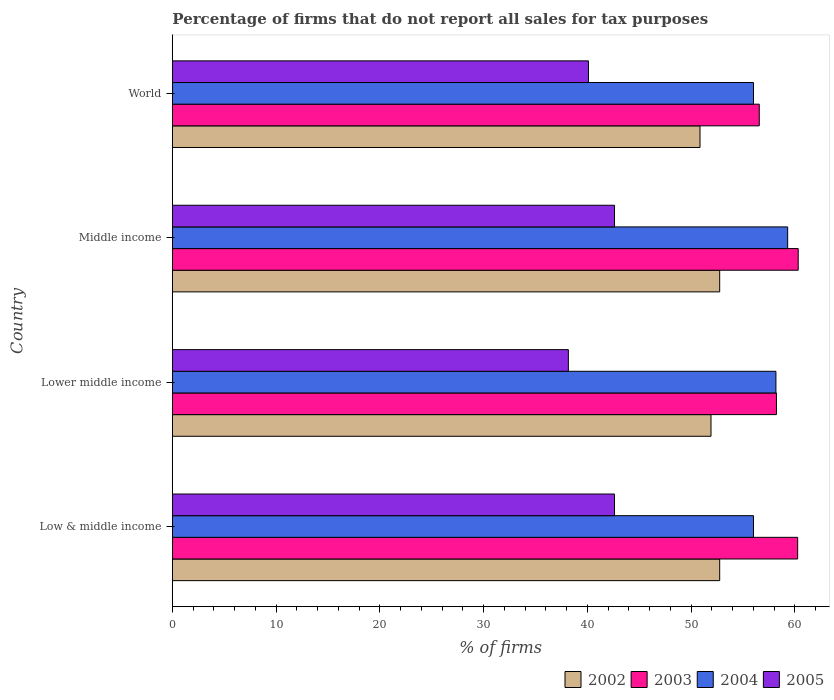How many groups of bars are there?
Ensure brevity in your answer.  4. How many bars are there on the 1st tick from the top?
Ensure brevity in your answer.  4. What is the label of the 3rd group of bars from the top?
Provide a short and direct response. Lower middle income. In how many cases, is the number of bars for a given country not equal to the number of legend labels?
Make the answer very short. 0. What is the percentage of firms that do not report all sales for tax purposes in 2005 in Low & middle income?
Offer a terse response. 42.61. Across all countries, what is the maximum percentage of firms that do not report all sales for tax purposes in 2003?
Keep it short and to the point. 60.31. Across all countries, what is the minimum percentage of firms that do not report all sales for tax purposes in 2004?
Provide a short and direct response. 56.01. In which country was the percentage of firms that do not report all sales for tax purposes in 2002 maximum?
Your answer should be very brief. Low & middle income. In which country was the percentage of firms that do not report all sales for tax purposes in 2002 minimum?
Give a very brief answer. World. What is the total percentage of firms that do not report all sales for tax purposes in 2004 in the graph?
Your response must be concise. 229.47. What is the difference between the percentage of firms that do not report all sales for tax purposes in 2004 in Middle income and the percentage of firms that do not report all sales for tax purposes in 2005 in World?
Provide a succinct answer. 19.2. What is the average percentage of firms that do not report all sales for tax purposes in 2002 per country?
Ensure brevity in your answer.  52.06. What is the difference between the percentage of firms that do not report all sales for tax purposes in 2003 and percentage of firms that do not report all sales for tax purposes in 2005 in Lower middle income?
Your answer should be compact. 20.06. In how many countries, is the percentage of firms that do not report all sales for tax purposes in 2004 greater than 48 %?
Provide a short and direct response. 4. What is the ratio of the percentage of firms that do not report all sales for tax purposes in 2002 in Low & middle income to that in Lower middle income?
Your response must be concise. 1.02. Is the difference between the percentage of firms that do not report all sales for tax purposes in 2003 in Middle income and World greater than the difference between the percentage of firms that do not report all sales for tax purposes in 2005 in Middle income and World?
Offer a terse response. Yes. What is the difference between the highest and the second highest percentage of firms that do not report all sales for tax purposes in 2004?
Your response must be concise. 1.13. What is the difference between the highest and the lowest percentage of firms that do not report all sales for tax purposes in 2002?
Your response must be concise. 1.89. In how many countries, is the percentage of firms that do not report all sales for tax purposes in 2005 greater than the average percentage of firms that do not report all sales for tax purposes in 2005 taken over all countries?
Your answer should be very brief. 2. Is the sum of the percentage of firms that do not report all sales for tax purposes in 2002 in Middle income and World greater than the maximum percentage of firms that do not report all sales for tax purposes in 2004 across all countries?
Your answer should be very brief. Yes. Is it the case that in every country, the sum of the percentage of firms that do not report all sales for tax purposes in 2002 and percentage of firms that do not report all sales for tax purposes in 2004 is greater than the sum of percentage of firms that do not report all sales for tax purposes in 2003 and percentage of firms that do not report all sales for tax purposes in 2005?
Your answer should be very brief. Yes. Is it the case that in every country, the sum of the percentage of firms that do not report all sales for tax purposes in 2003 and percentage of firms that do not report all sales for tax purposes in 2005 is greater than the percentage of firms that do not report all sales for tax purposes in 2004?
Offer a very short reply. Yes. How many bars are there?
Your response must be concise. 16. Are all the bars in the graph horizontal?
Your response must be concise. Yes. Does the graph contain any zero values?
Your answer should be compact. No. Does the graph contain grids?
Offer a terse response. No. Where does the legend appear in the graph?
Provide a succinct answer. Bottom right. How are the legend labels stacked?
Give a very brief answer. Horizontal. What is the title of the graph?
Your answer should be very brief. Percentage of firms that do not report all sales for tax purposes. What is the label or title of the X-axis?
Your answer should be compact. % of firms. What is the label or title of the Y-axis?
Give a very brief answer. Country. What is the % of firms of 2002 in Low & middle income?
Provide a succinct answer. 52.75. What is the % of firms in 2003 in Low & middle income?
Give a very brief answer. 60.26. What is the % of firms of 2004 in Low & middle income?
Your answer should be compact. 56.01. What is the % of firms of 2005 in Low & middle income?
Provide a succinct answer. 42.61. What is the % of firms in 2002 in Lower middle income?
Keep it short and to the point. 51.91. What is the % of firms in 2003 in Lower middle income?
Ensure brevity in your answer.  58.22. What is the % of firms in 2004 in Lower middle income?
Give a very brief answer. 58.16. What is the % of firms in 2005 in Lower middle income?
Provide a succinct answer. 38.16. What is the % of firms in 2002 in Middle income?
Ensure brevity in your answer.  52.75. What is the % of firms of 2003 in Middle income?
Your answer should be very brief. 60.31. What is the % of firms in 2004 in Middle income?
Keep it short and to the point. 59.3. What is the % of firms in 2005 in Middle income?
Provide a short and direct response. 42.61. What is the % of firms in 2002 in World?
Provide a succinct answer. 50.85. What is the % of firms in 2003 in World?
Offer a terse response. 56.56. What is the % of firms of 2004 in World?
Your response must be concise. 56.01. What is the % of firms of 2005 in World?
Your response must be concise. 40.1. Across all countries, what is the maximum % of firms in 2002?
Your answer should be compact. 52.75. Across all countries, what is the maximum % of firms of 2003?
Ensure brevity in your answer.  60.31. Across all countries, what is the maximum % of firms in 2004?
Provide a succinct answer. 59.3. Across all countries, what is the maximum % of firms of 2005?
Provide a succinct answer. 42.61. Across all countries, what is the minimum % of firms in 2002?
Offer a very short reply. 50.85. Across all countries, what is the minimum % of firms of 2003?
Offer a terse response. 56.56. Across all countries, what is the minimum % of firms of 2004?
Ensure brevity in your answer.  56.01. Across all countries, what is the minimum % of firms in 2005?
Offer a very short reply. 38.16. What is the total % of firms in 2002 in the graph?
Ensure brevity in your answer.  208.25. What is the total % of firms in 2003 in the graph?
Offer a very short reply. 235.35. What is the total % of firms of 2004 in the graph?
Give a very brief answer. 229.47. What is the total % of firms of 2005 in the graph?
Your answer should be very brief. 163.48. What is the difference between the % of firms in 2002 in Low & middle income and that in Lower middle income?
Provide a short and direct response. 0.84. What is the difference between the % of firms of 2003 in Low & middle income and that in Lower middle income?
Your answer should be compact. 2.04. What is the difference between the % of firms in 2004 in Low & middle income and that in Lower middle income?
Your answer should be compact. -2.16. What is the difference between the % of firms of 2005 in Low & middle income and that in Lower middle income?
Offer a terse response. 4.45. What is the difference between the % of firms of 2002 in Low & middle income and that in Middle income?
Give a very brief answer. 0. What is the difference between the % of firms in 2003 in Low & middle income and that in Middle income?
Provide a short and direct response. -0.05. What is the difference between the % of firms of 2004 in Low & middle income and that in Middle income?
Make the answer very short. -3.29. What is the difference between the % of firms of 2005 in Low & middle income and that in Middle income?
Give a very brief answer. 0. What is the difference between the % of firms of 2002 in Low & middle income and that in World?
Your answer should be very brief. 1.89. What is the difference between the % of firms of 2003 in Low & middle income and that in World?
Provide a short and direct response. 3.7. What is the difference between the % of firms in 2004 in Low & middle income and that in World?
Provide a succinct answer. 0. What is the difference between the % of firms in 2005 in Low & middle income and that in World?
Ensure brevity in your answer.  2.51. What is the difference between the % of firms of 2002 in Lower middle income and that in Middle income?
Give a very brief answer. -0.84. What is the difference between the % of firms of 2003 in Lower middle income and that in Middle income?
Your answer should be compact. -2.09. What is the difference between the % of firms of 2004 in Lower middle income and that in Middle income?
Provide a short and direct response. -1.13. What is the difference between the % of firms in 2005 in Lower middle income and that in Middle income?
Provide a short and direct response. -4.45. What is the difference between the % of firms in 2002 in Lower middle income and that in World?
Provide a short and direct response. 1.06. What is the difference between the % of firms in 2003 in Lower middle income and that in World?
Your response must be concise. 1.66. What is the difference between the % of firms of 2004 in Lower middle income and that in World?
Ensure brevity in your answer.  2.16. What is the difference between the % of firms in 2005 in Lower middle income and that in World?
Ensure brevity in your answer.  -1.94. What is the difference between the % of firms in 2002 in Middle income and that in World?
Your answer should be compact. 1.89. What is the difference between the % of firms of 2003 in Middle income and that in World?
Provide a short and direct response. 3.75. What is the difference between the % of firms in 2004 in Middle income and that in World?
Offer a terse response. 3.29. What is the difference between the % of firms in 2005 in Middle income and that in World?
Provide a short and direct response. 2.51. What is the difference between the % of firms of 2002 in Low & middle income and the % of firms of 2003 in Lower middle income?
Provide a succinct answer. -5.47. What is the difference between the % of firms of 2002 in Low & middle income and the % of firms of 2004 in Lower middle income?
Keep it short and to the point. -5.42. What is the difference between the % of firms in 2002 in Low & middle income and the % of firms in 2005 in Lower middle income?
Your response must be concise. 14.58. What is the difference between the % of firms of 2003 in Low & middle income and the % of firms of 2004 in Lower middle income?
Offer a very short reply. 2.1. What is the difference between the % of firms in 2003 in Low & middle income and the % of firms in 2005 in Lower middle income?
Your answer should be very brief. 22.1. What is the difference between the % of firms in 2004 in Low & middle income and the % of firms in 2005 in Lower middle income?
Offer a terse response. 17.84. What is the difference between the % of firms of 2002 in Low & middle income and the % of firms of 2003 in Middle income?
Make the answer very short. -7.57. What is the difference between the % of firms of 2002 in Low & middle income and the % of firms of 2004 in Middle income?
Your answer should be very brief. -6.55. What is the difference between the % of firms in 2002 in Low & middle income and the % of firms in 2005 in Middle income?
Your answer should be very brief. 10.13. What is the difference between the % of firms of 2003 in Low & middle income and the % of firms of 2004 in Middle income?
Your answer should be very brief. 0.96. What is the difference between the % of firms in 2003 in Low & middle income and the % of firms in 2005 in Middle income?
Keep it short and to the point. 17.65. What is the difference between the % of firms of 2004 in Low & middle income and the % of firms of 2005 in Middle income?
Keep it short and to the point. 13.39. What is the difference between the % of firms of 2002 in Low & middle income and the % of firms of 2003 in World?
Your response must be concise. -3.81. What is the difference between the % of firms in 2002 in Low & middle income and the % of firms in 2004 in World?
Keep it short and to the point. -3.26. What is the difference between the % of firms in 2002 in Low & middle income and the % of firms in 2005 in World?
Offer a very short reply. 12.65. What is the difference between the % of firms of 2003 in Low & middle income and the % of firms of 2004 in World?
Your response must be concise. 4.25. What is the difference between the % of firms of 2003 in Low & middle income and the % of firms of 2005 in World?
Give a very brief answer. 20.16. What is the difference between the % of firms in 2004 in Low & middle income and the % of firms in 2005 in World?
Offer a very short reply. 15.91. What is the difference between the % of firms in 2002 in Lower middle income and the % of firms in 2003 in Middle income?
Keep it short and to the point. -8.4. What is the difference between the % of firms in 2002 in Lower middle income and the % of firms in 2004 in Middle income?
Make the answer very short. -7.39. What is the difference between the % of firms of 2002 in Lower middle income and the % of firms of 2005 in Middle income?
Your answer should be compact. 9.3. What is the difference between the % of firms of 2003 in Lower middle income and the % of firms of 2004 in Middle income?
Offer a terse response. -1.08. What is the difference between the % of firms of 2003 in Lower middle income and the % of firms of 2005 in Middle income?
Your answer should be very brief. 15.61. What is the difference between the % of firms in 2004 in Lower middle income and the % of firms in 2005 in Middle income?
Offer a very short reply. 15.55. What is the difference between the % of firms of 2002 in Lower middle income and the % of firms of 2003 in World?
Provide a succinct answer. -4.65. What is the difference between the % of firms in 2002 in Lower middle income and the % of firms in 2004 in World?
Offer a very short reply. -4.1. What is the difference between the % of firms of 2002 in Lower middle income and the % of firms of 2005 in World?
Provide a succinct answer. 11.81. What is the difference between the % of firms of 2003 in Lower middle income and the % of firms of 2004 in World?
Your response must be concise. 2.21. What is the difference between the % of firms in 2003 in Lower middle income and the % of firms in 2005 in World?
Keep it short and to the point. 18.12. What is the difference between the % of firms in 2004 in Lower middle income and the % of firms in 2005 in World?
Offer a terse response. 18.07. What is the difference between the % of firms of 2002 in Middle income and the % of firms of 2003 in World?
Make the answer very short. -3.81. What is the difference between the % of firms of 2002 in Middle income and the % of firms of 2004 in World?
Your answer should be compact. -3.26. What is the difference between the % of firms of 2002 in Middle income and the % of firms of 2005 in World?
Your answer should be very brief. 12.65. What is the difference between the % of firms of 2003 in Middle income and the % of firms of 2004 in World?
Ensure brevity in your answer.  4.31. What is the difference between the % of firms of 2003 in Middle income and the % of firms of 2005 in World?
Your answer should be compact. 20.21. What is the difference between the % of firms of 2004 in Middle income and the % of firms of 2005 in World?
Your answer should be compact. 19.2. What is the average % of firms of 2002 per country?
Make the answer very short. 52.06. What is the average % of firms in 2003 per country?
Provide a short and direct response. 58.84. What is the average % of firms in 2004 per country?
Provide a succinct answer. 57.37. What is the average % of firms of 2005 per country?
Offer a very short reply. 40.87. What is the difference between the % of firms in 2002 and % of firms in 2003 in Low & middle income?
Your answer should be compact. -7.51. What is the difference between the % of firms of 2002 and % of firms of 2004 in Low & middle income?
Your answer should be very brief. -3.26. What is the difference between the % of firms in 2002 and % of firms in 2005 in Low & middle income?
Provide a short and direct response. 10.13. What is the difference between the % of firms in 2003 and % of firms in 2004 in Low & middle income?
Your response must be concise. 4.25. What is the difference between the % of firms of 2003 and % of firms of 2005 in Low & middle income?
Ensure brevity in your answer.  17.65. What is the difference between the % of firms in 2004 and % of firms in 2005 in Low & middle income?
Give a very brief answer. 13.39. What is the difference between the % of firms in 2002 and % of firms in 2003 in Lower middle income?
Keep it short and to the point. -6.31. What is the difference between the % of firms in 2002 and % of firms in 2004 in Lower middle income?
Offer a very short reply. -6.26. What is the difference between the % of firms of 2002 and % of firms of 2005 in Lower middle income?
Your answer should be compact. 13.75. What is the difference between the % of firms of 2003 and % of firms of 2004 in Lower middle income?
Give a very brief answer. 0.05. What is the difference between the % of firms of 2003 and % of firms of 2005 in Lower middle income?
Ensure brevity in your answer.  20.06. What is the difference between the % of firms of 2004 and % of firms of 2005 in Lower middle income?
Your response must be concise. 20. What is the difference between the % of firms of 2002 and % of firms of 2003 in Middle income?
Your response must be concise. -7.57. What is the difference between the % of firms of 2002 and % of firms of 2004 in Middle income?
Keep it short and to the point. -6.55. What is the difference between the % of firms in 2002 and % of firms in 2005 in Middle income?
Your answer should be compact. 10.13. What is the difference between the % of firms of 2003 and % of firms of 2004 in Middle income?
Provide a succinct answer. 1.02. What is the difference between the % of firms of 2003 and % of firms of 2005 in Middle income?
Keep it short and to the point. 17.7. What is the difference between the % of firms of 2004 and % of firms of 2005 in Middle income?
Your answer should be compact. 16.69. What is the difference between the % of firms in 2002 and % of firms in 2003 in World?
Ensure brevity in your answer.  -5.71. What is the difference between the % of firms in 2002 and % of firms in 2004 in World?
Offer a terse response. -5.15. What is the difference between the % of firms in 2002 and % of firms in 2005 in World?
Offer a very short reply. 10.75. What is the difference between the % of firms in 2003 and % of firms in 2004 in World?
Give a very brief answer. 0.56. What is the difference between the % of firms in 2003 and % of firms in 2005 in World?
Your response must be concise. 16.46. What is the difference between the % of firms in 2004 and % of firms in 2005 in World?
Offer a terse response. 15.91. What is the ratio of the % of firms of 2002 in Low & middle income to that in Lower middle income?
Offer a very short reply. 1.02. What is the ratio of the % of firms in 2003 in Low & middle income to that in Lower middle income?
Keep it short and to the point. 1.04. What is the ratio of the % of firms in 2004 in Low & middle income to that in Lower middle income?
Offer a terse response. 0.96. What is the ratio of the % of firms in 2005 in Low & middle income to that in Lower middle income?
Your answer should be compact. 1.12. What is the ratio of the % of firms in 2004 in Low & middle income to that in Middle income?
Offer a terse response. 0.94. What is the ratio of the % of firms in 2002 in Low & middle income to that in World?
Offer a terse response. 1.04. What is the ratio of the % of firms in 2003 in Low & middle income to that in World?
Keep it short and to the point. 1.07. What is the ratio of the % of firms of 2004 in Low & middle income to that in World?
Ensure brevity in your answer.  1. What is the ratio of the % of firms of 2005 in Low & middle income to that in World?
Offer a terse response. 1.06. What is the ratio of the % of firms of 2002 in Lower middle income to that in Middle income?
Your response must be concise. 0.98. What is the ratio of the % of firms of 2003 in Lower middle income to that in Middle income?
Ensure brevity in your answer.  0.97. What is the ratio of the % of firms in 2004 in Lower middle income to that in Middle income?
Provide a succinct answer. 0.98. What is the ratio of the % of firms in 2005 in Lower middle income to that in Middle income?
Provide a succinct answer. 0.9. What is the ratio of the % of firms in 2002 in Lower middle income to that in World?
Ensure brevity in your answer.  1.02. What is the ratio of the % of firms in 2003 in Lower middle income to that in World?
Provide a succinct answer. 1.03. What is the ratio of the % of firms of 2004 in Lower middle income to that in World?
Make the answer very short. 1.04. What is the ratio of the % of firms in 2005 in Lower middle income to that in World?
Make the answer very short. 0.95. What is the ratio of the % of firms in 2002 in Middle income to that in World?
Keep it short and to the point. 1.04. What is the ratio of the % of firms in 2003 in Middle income to that in World?
Your answer should be compact. 1.07. What is the ratio of the % of firms of 2004 in Middle income to that in World?
Provide a short and direct response. 1.06. What is the ratio of the % of firms in 2005 in Middle income to that in World?
Provide a short and direct response. 1.06. What is the difference between the highest and the second highest % of firms of 2003?
Ensure brevity in your answer.  0.05. What is the difference between the highest and the second highest % of firms of 2004?
Make the answer very short. 1.13. What is the difference between the highest and the lowest % of firms of 2002?
Your answer should be very brief. 1.89. What is the difference between the highest and the lowest % of firms in 2003?
Give a very brief answer. 3.75. What is the difference between the highest and the lowest % of firms of 2004?
Provide a short and direct response. 3.29. What is the difference between the highest and the lowest % of firms in 2005?
Your response must be concise. 4.45. 